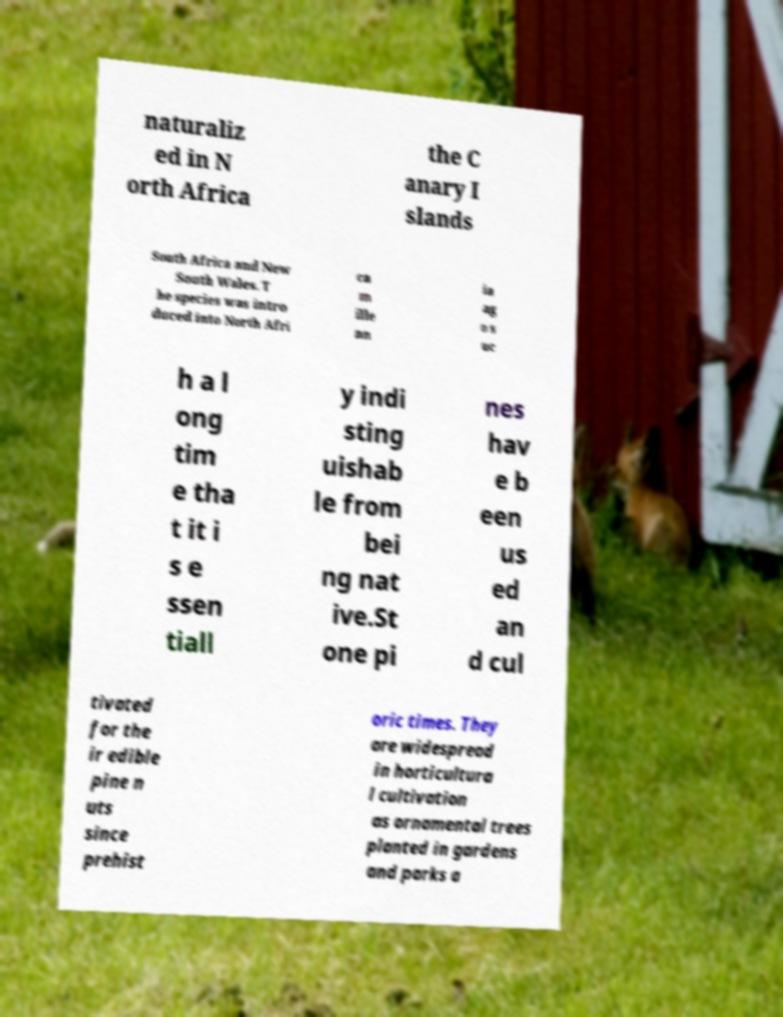I need the written content from this picture converted into text. Can you do that? naturaliz ed in N orth Africa the C anary I slands South Africa and New South Wales. T he species was intro duced into North Afri ca m ille nn ia ag o s uc h a l ong tim e tha t it i s e ssen tiall y indi sting uishab le from bei ng nat ive.St one pi nes hav e b een us ed an d cul tivated for the ir edible pine n uts since prehist oric times. They are widespread in horticultura l cultivation as ornamental trees planted in gardens and parks a 